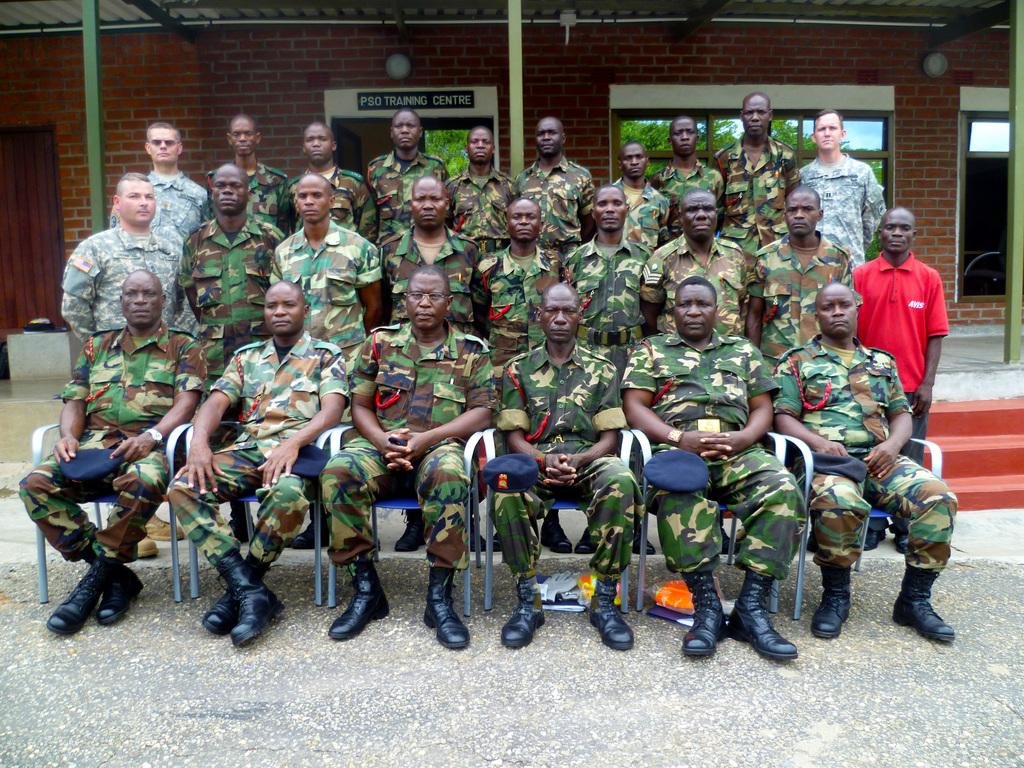What are the people in the image doing? There are people sitting on chairs and standing on a path in the image. What can be seen in the background of the image? There are poles visible in the image, as well as a wall with windows. What is attached to the wall in the image? There are lights on the wall in the image. What type of cork can be seen on the path in the image? There is no cork present on the path in the image. What direction are the people facing in the image? The image does not provide information about the direction the people are facing. 